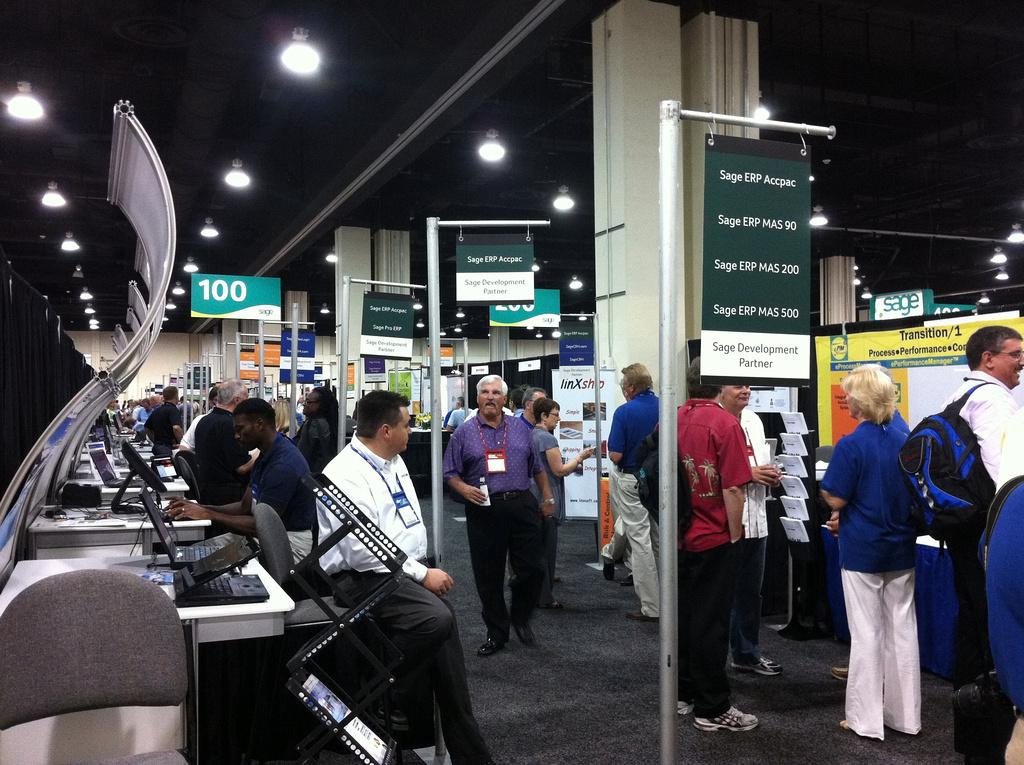What are the people on the left side of the image doing? The people on the left side of the image are sitting on chairs and working on computers. What can be seen on the right side of the image? On the right side of the image, there are people, hoardings, poles, and banners. Can you describe the lights in the image? There are lights on the rooftop in the image. How many donkeys are present in the image? There are no donkeys present in the image. What is the size of the meeting in the image? There is no meeting depicted in the image. 